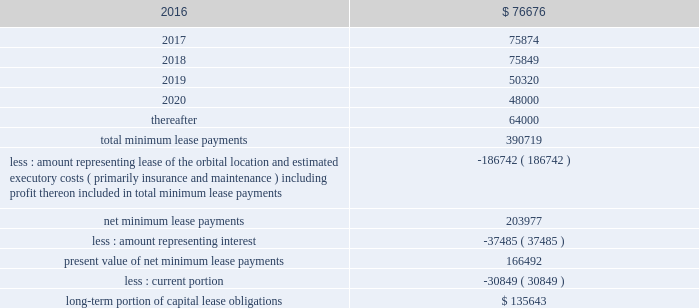Dish network corporation notes to consolidated financial statements - continued future minimum lease payments under the capital lease obligations , together with the present value of the net minimum lease payments as of december 31 , 2015 are as follows ( in thousands ) : for the years ended december 31 .
The summary of future maturities of our outstanding long-term debt as of december 31 , 2015 is included in the commitments table in note 15 .
11 .
Income taxes and accounting for uncertainty in income taxes income taxes our income tax policy is to record the estimated future tax effects of temporary differences between the tax bases of assets and liabilities and amounts reported on our consolidated balance sheets , as well as probable operating loss , tax credit and other carryforwards .
Deferred tax assets are offset by valuation allowances when we believe it is more likely than not that net deferred tax assets will not be realized .
We periodically evaluate our need for a valuation allowance .
Determining necessary valuation allowances requires us to make assessments about historical financial information as well as the timing of future events , including the probability of expected future taxable income and available tax planning opportunities .
We file consolidated tax returns in the u.s .
The income taxes of domestic and foreign subsidiaries not included in the u.s .
Tax group are presented in our consolidated financial statements on a separate return basis for each tax paying entity .
As of december 31 , 2015 , we had no net operating loss carryforwards ( 201cnols 201d ) for federal income tax purposes and $ 39 million of nol benefit for state income tax purposes , which are partially offset by a valuation allowance .
The state nols begin to expire in the year 2017 .
In addition , there are $ 61 million of tax benefits related to credit carryforwards which are partially offset by a valuation allowance .
The state credit carryforwards began to expire in .
What percentage of future minimum lease payments under the capital lease obligations is due after 2020? 
Computations: (64000 / 390719)
Answer: 0.1638. 